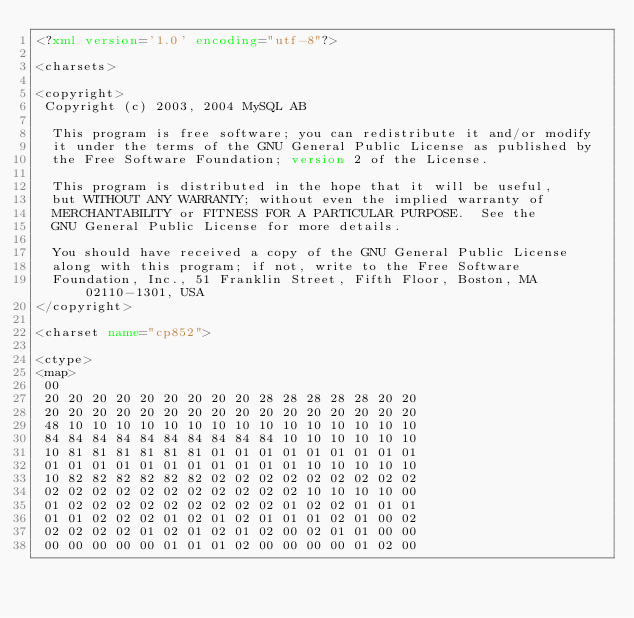<code> <loc_0><loc_0><loc_500><loc_500><_XML_><?xml version='1.0' encoding="utf-8"?>

<charsets>

<copyright>
 Copyright (c) 2003, 2004 MySQL AB

  This program is free software; you can redistribute it and/or modify
  it under the terms of the GNU General Public License as published by
  the Free Software Foundation; version 2 of the License.

  This program is distributed in the hope that it will be useful,
  but WITHOUT ANY WARRANTY; without even the implied warranty of
  MERCHANTABILITY or FITNESS FOR A PARTICULAR PURPOSE.  See the
  GNU General Public License for more details.

  You should have received a copy of the GNU General Public License
  along with this program; if not, write to the Free Software
  Foundation, Inc., 51 Franklin Street, Fifth Floor, Boston, MA  02110-1301, USA
</copyright>

<charset name="cp852">

<ctype>
<map>
 00
 20 20 20 20 20 20 20 20 20 28 28 28 28 28 20 20
 20 20 20 20 20 20 20 20 20 20 20 20 20 20 20 20
 48 10 10 10 10 10 10 10 10 10 10 10 10 10 10 10
 84 84 84 84 84 84 84 84 84 84 10 10 10 10 10 10
 10 81 81 81 81 81 81 01 01 01 01 01 01 01 01 01
 01 01 01 01 01 01 01 01 01 01 01 10 10 10 10 10
 10 82 82 82 82 82 82 02 02 02 02 02 02 02 02 02
 02 02 02 02 02 02 02 02 02 02 02 10 10 10 10 00
 01 02 02 02 02 02 02 02 02 02 01 02 02 01 01 01
 01 01 02 02 02 01 02 01 02 01 01 01 02 01 00 02
 02 02 02 02 01 02 01 02 01 02 00 02 01 01 00 00
 00 00 00 00 00 01 01 01 02 00 00 00 00 01 02 00</code> 